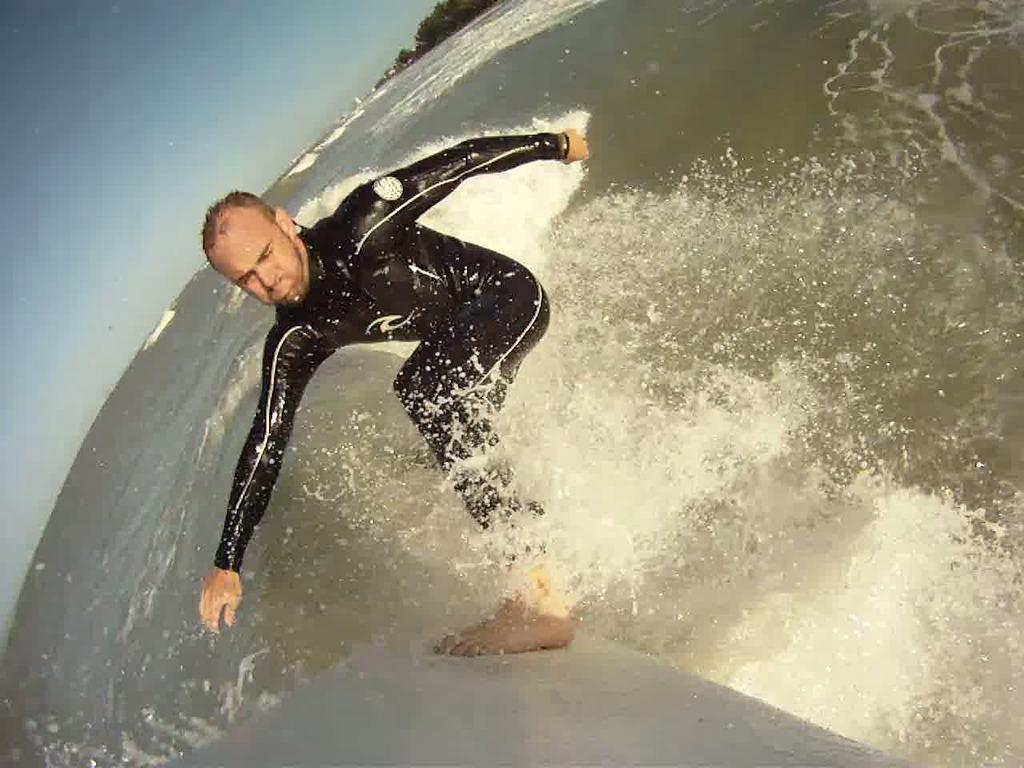Who is the main subject in the image? There is a man in the image. What is the man doing in the image? The man is surfing on the surface of the water. What can be seen in the background of the image? There are trees and the sky visible in the image. What type of structure is being built in the image? There is no structure being built in the image; it features a man surfing on the water with trees and the sky visible in the background. 